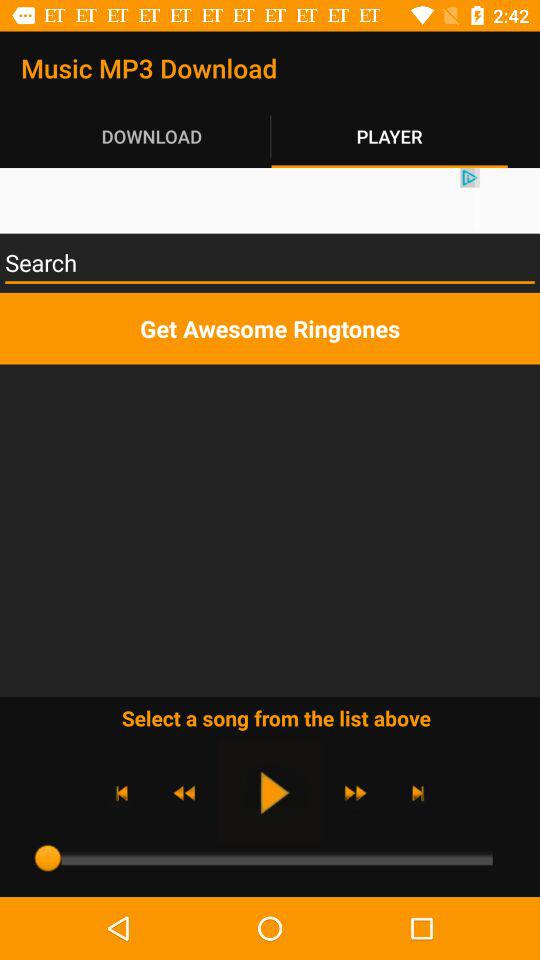Which tab am I on? You are on the "DOWNLOAD" tab. 